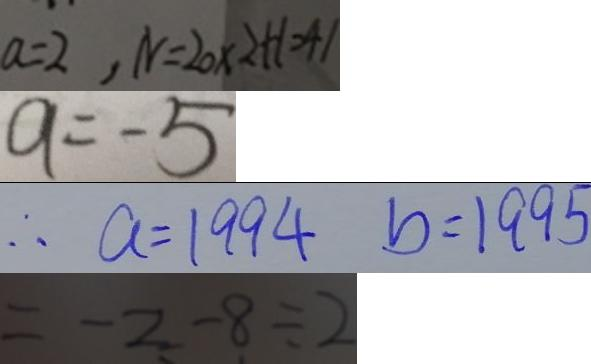<formula> <loc_0><loc_0><loc_500><loc_500>a = 2 , N = 2 0 \times 2 + 1 = 4 1 
 a = - 5 
 \therefore a = 1 9 9 4 b = 1 9 9 5 
 = - 2 - 8 \div 2</formula> 